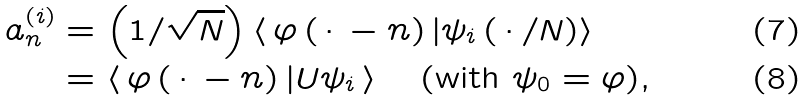<formula> <loc_0><loc_0><loc_500><loc_500>a _ { n } ^ { \left ( i \right ) } & = \left ( 1 / \sqrt { N } \right ) \left \langle \, \varphi \left ( \, \cdot \, - n \right ) | \psi _ { i } \left ( \, \cdot \, / N \right ) \right \rangle \\ & = \left \langle \, \varphi \left ( \, \cdot \, - n \right ) | U \psi _ { i } \, \right \rangle \text {\quad (with } \psi _ { 0 } = \varphi \text {),}</formula> 